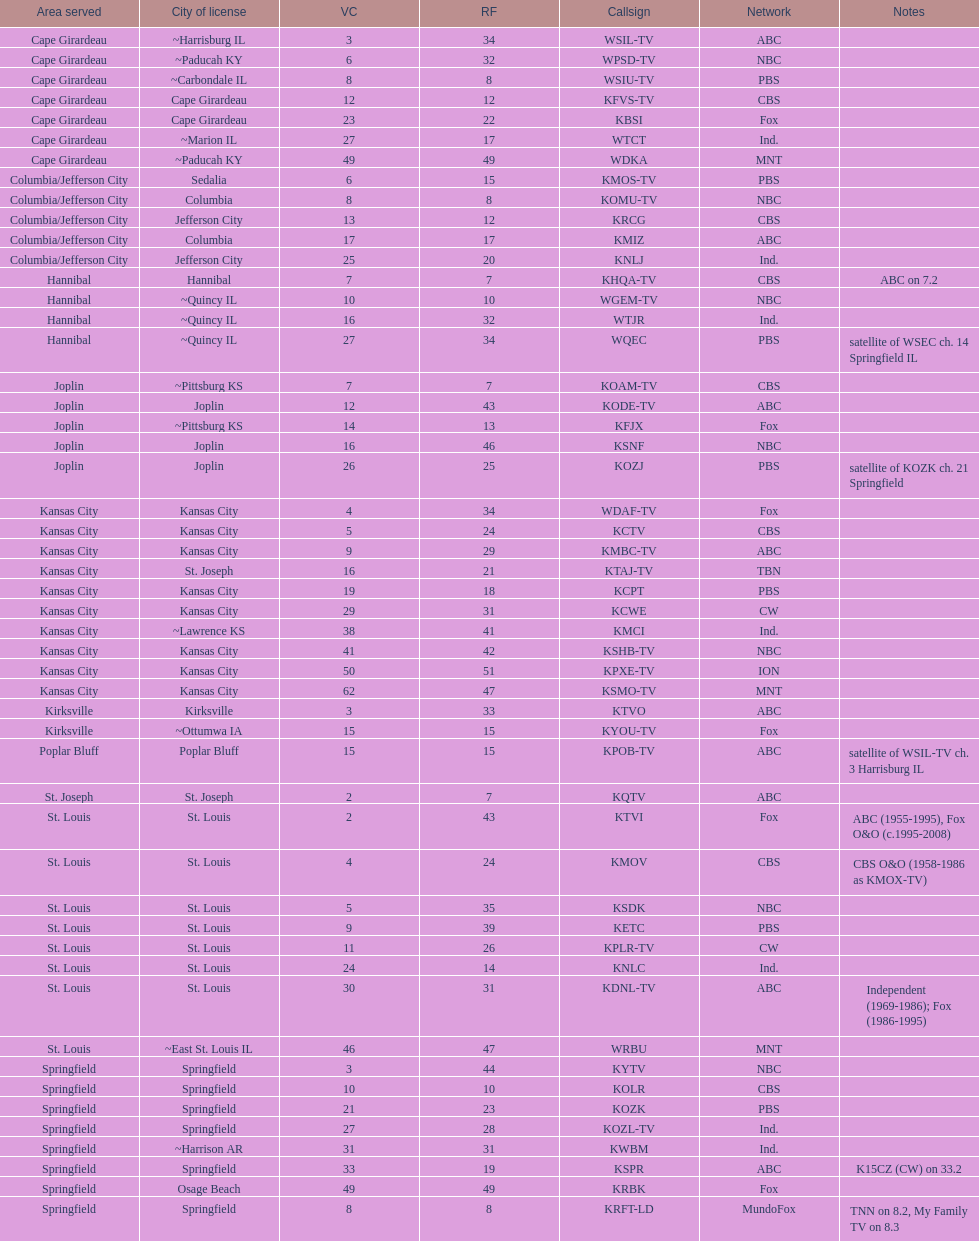Could you parse the entire table as a dict? {'header': ['Area served', 'City of license', 'VC', 'RF', 'Callsign', 'Network', 'Notes'], 'rows': [['Cape Girardeau', '~Harrisburg IL', '3', '34', 'WSIL-TV', 'ABC', ''], ['Cape Girardeau', '~Paducah KY', '6', '32', 'WPSD-TV', 'NBC', ''], ['Cape Girardeau', '~Carbondale IL', '8', '8', 'WSIU-TV', 'PBS', ''], ['Cape Girardeau', 'Cape Girardeau', '12', '12', 'KFVS-TV', 'CBS', ''], ['Cape Girardeau', 'Cape Girardeau', '23', '22', 'KBSI', 'Fox', ''], ['Cape Girardeau', '~Marion IL', '27', '17', 'WTCT', 'Ind.', ''], ['Cape Girardeau', '~Paducah KY', '49', '49', 'WDKA', 'MNT', ''], ['Columbia/Jefferson City', 'Sedalia', '6', '15', 'KMOS-TV', 'PBS', ''], ['Columbia/Jefferson City', 'Columbia', '8', '8', 'KOMU-TV', 'NBC', ''], ['Columbia/Jefferson City', 'Jefferson City', '13', '12', 'KRCG', 'CBS', ''], ['Columbia/Jefferson City', 'Columbia', '17', '17', 'KMIZ', 'ABC', ''], ['Columbia/Jefferson City', 'Jefferson City', '25', '20', 'KNLJ', 'Ind.', ''], ['Hannibal', 'Hannibal', '7', '7', 'KHQA-TV', 'CBS', 'ABC on 7.2'], ['Hannibal', '~Quincy IL', '10', '10', 'WGEM-TV', 'NBC', ''], ['Hannibal', '~Quincy IL', '16', '32', 'WTJR', 'Ind.', ''], ['Hannibal', '~Quincy IL', '27', '34', 'WQEC', 'PBS', 'satellite of WSEC ch. 14 Springfield IL'], ['Joplin', '~Pittsburg KS', '7', '7', 'KOAM-TV', 'CBS', ''], ['Joplin', 'Joplin', '12', '43', 'KODE-TV', 'ABC', ''], ['Joplin', '~Pittsburg KS', '14', '13', 'KFJX', 'Fox', ''], ['Joplin', 'Joplin', '16', '46', 'KSNF', 'NBC', ''], ['Joplin', 'Joplin', '26', '25', 'KOZJ', 'PBS', 'satellite of KOZK ch. 21 Springfield'], ['Kansas City', 'Kansas City', '4', '34', 'WDAF-TV', 'Fox', ''], ['Kansas City', 'Kansas City', '5', '24', 'KCTV', 'CBS', ''], ['Kansas City', 'Kansas City', '9', '29', 'KMBC-TV', 'ABC', ''], ['Kansas City', 'St. Joseph', '16', '21', 'KTAJ-TV', 'TBN', ''], ['Kansas City', 'Kansas City', '19', '18', 'KCPT', 'PBS', ''], ['Kansas City', 'Kansas City', '29', '31', 'KCWE', 'CW', ''], ['Kansas City', '~Lawrence KS', '38', '41', 'KMCI', 'Ind.', ''], ['Kansas City', 'Kansas City', '41', '42', 'KSHB-TV', 'NBC', ''], ['Kansas City', 'Kansas City', '50', '51', 'KPXE-TV', 'ION', ''], ['Kansas City', 'Kansas City', '62', '47', 'KSMO-TV', 'MNT', ''], ['Kirksville', 'Kirksville', '3', '33', 'KTVO', 'ABC', ''], ['Kirksville', '~Ottumwa IA', '15', '15', 'KYOU-TV', 'Fox', ''], ['Poplar Bluff', 'Poplar Bluff', '15', '15', 'KPOB-TV', 'ABC', 'satellite of WSIL-TV ch. 3 Harrisburg IL'], ['St. Joseph', 'St. Joseph', '2', '7', 'KQTV', 'ABC', ''], ['St. Louis', 'St. Louis', '2', '43', 'KTVI', 'Fox', 'ABC (1955-1995), Fox O&O (c.1995-2008)'], ['St. Louis', 'St. Louis', '4', '24', 'KMOV', 'CBS', 'CBS O&O (1958-1986 as KMOX-TV)'], ['St. Louis', 'St. Louis', '5', '35', 'KSDK', 'NBC', ''], ['St. Louis', 'St. Louis', '9', '39', 'KETC', 'PBS', ''], ['St. Louis', 'St. Louis', '11', '26', 'KPLR-TV', 'CW', ''], ['St. Louis', 'St. Louis', '24', '14', 'KNLC', 'Ind.', ''], ['St. Louis', 'St. Louis', '30', '31', 'KDNL-TV', 'ABC', 'Independent (1969-1986); Fox (1986-1995)'], ['St. Louis', '~East St. Louis IL', '46', '47', 'WRBU', 'MNT', ''], ['Springfield', 'Springfield', '3', '44', 'KYTV', 'NBC', ''], ['Springfield', 'Springfield', '10', '10', 'KOLR', 'CBS', ''], ['Springfield', 'Springfield', '21', '23', 'KOZK', 'PBS', ''], ['Springfield', 'Springfield', '27', '28', 'KOZL-TV', 'Ind.', ''], ['Springfield', '~Harrison AR', '31', '31', 'KWBM', 'Ind.', ''], ['Springfield', 'Springfield', '33', '19', 'KSPR', 'ABC', 'K15CZ (CW) on 33.2'], ['Springfield', 'Osage Beach', '49', '49', 'KRBK', 'Fox', ''], ['Springfield', 'Springfield', '8', '8', 'KRFT-LD', 'MundoFox', 'TNN on 8.2, My Family TV on 8.3']]} Which network includes both kode-tv and wsil-tv as its members? ABC. 